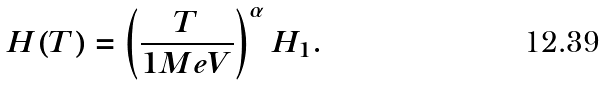<formula> <loc_0><loc_0><loc_500><loc_500>H ( T ) = \left ( \frac { T } { 1 M e V } \right ) ^ { \alpha } H _ { 1 } .</formula> 